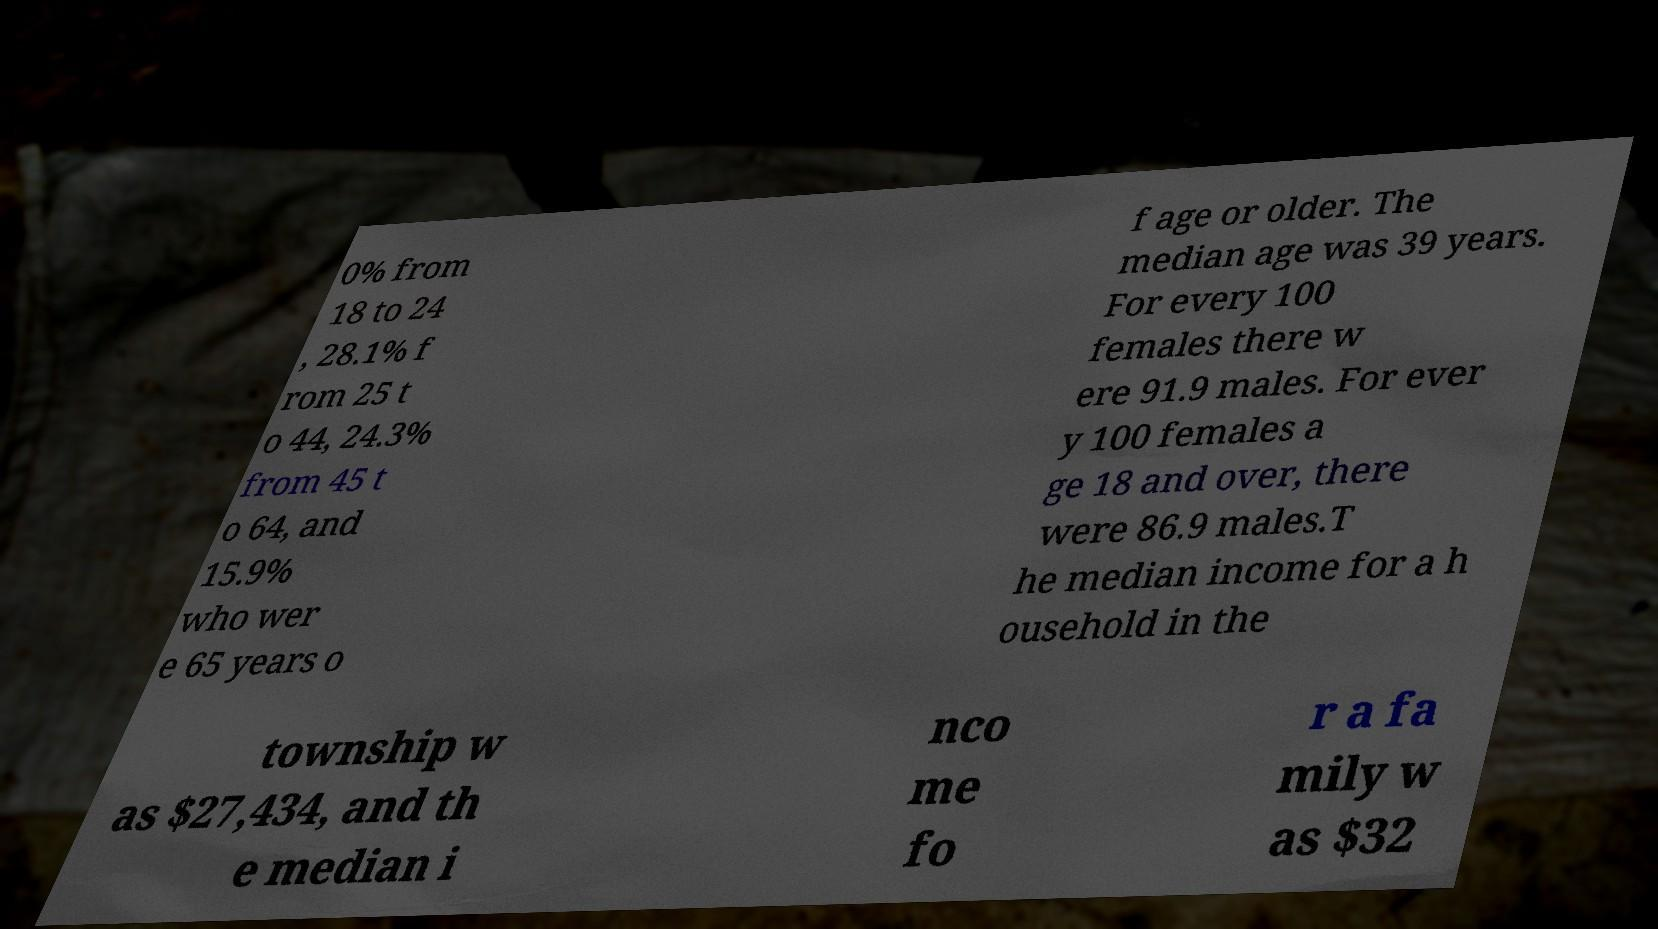What messages or text are displayed in this image? I need them in a readable, typed format. 0% from 18 to 24 , 28.1% f rom 25 t o 44, 24.3% from 45 t o 64, and 15.9% who wer e 65 years o f age or older. The median age was 39 years. For every 100 females there w ere 91.9 males. For ever y 100 females a ge 18 and over, there were 86.9 males.T he median income for a h ousehold in the township w as $27,434, and th e median i nco me fo r a fa mily w as $32 